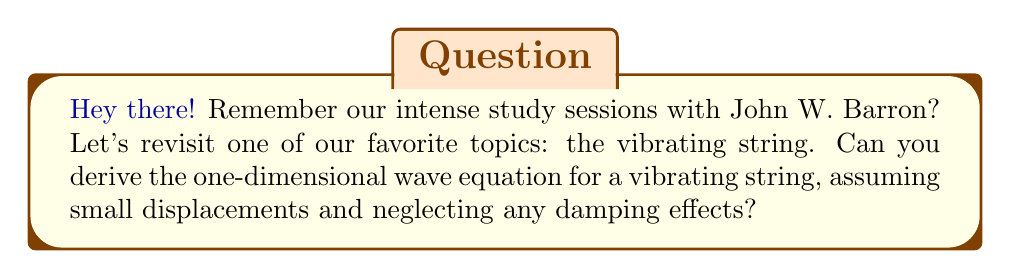Solve this math problem. Alright, let's break this down step-by-step, just like we used to do in our study sessions:

1) Consider a small segment of the string with length $\Delta x$. Let $y(x,t)$ be the vertical displacement of the string at position $x$ and time $t$.

2) The tension $T$ in the string is assumed to be constant. The angle the string makes with the horizontal at point $(x,t)$ is approximately $\frac{\partial y}{\partial x}$.

3) The vertical component of the tension force at $x$ is:
   $$F_1 = T \sin\theta_1 \approx T \frac{\partial y}{\partial x}|_x$$

4) Similarly, at $x + \Delta x$:
   $$F_2 = -T \sin\theta_2 \approx -T \frac{\partial y}{\partial x}|_{x+\Delta x}$$

5) The net force on the segment is:
   $$F_{net} = F_1 + F_2 \approx T\left(\frac{\partial y}{\partial x}|_x - \frac{\partial y}{\partial x}|_{x+\Delta x}\right)$$

6) Using the definition of partial derivative:
   $$F_{net} \approx -T\frac{\partial^2 y}{\partial x^2}\Delta x$$

7) From Newton's second law, $F = ma$, where $m = \rho \Delta x$ ($\rho$ is the linear mass density):
   $$-T\frac{\partial^2 y}{\partial x^2}\Delta x = \rho \Delta x \frac{\partial^2 y}{\partial t^2}$$

8) Dividing both sides by $\rho \Delta x$:
   $$\frac{\partial^2 y}{\partial t^2} = \frac{T}{\rho}\frac{\partial^2 y}{\partial x^2}$$

9) Define the wave speed $c = \sqrt{\frac{T}{\rho}}$, then we get the one-dimensional wave equation:
   $$\frac{\partial^2 y}{\partial t^2} = c^2\frac{\partial^2 y}{\partial x^2}$$
Answer: $$\frac{\partial^2 y}{\partial t^2} = c^2\frac{\partial^2 y}{\partial x^2}$$ 